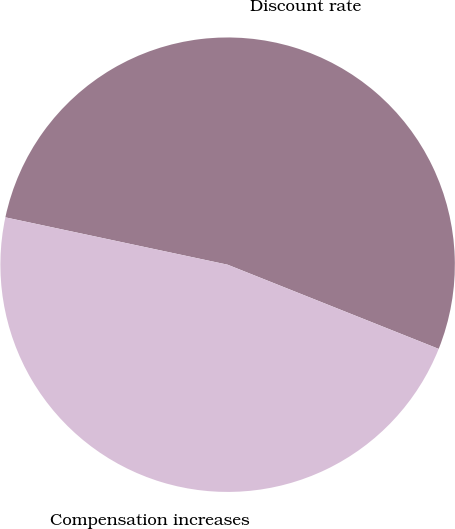Convert chart. <chart><loc_0><loc_0><loc_500><loc_500><pie_chart><fcel>Discount rate<fcel>Compensation increases<nl><fcel>52.7%<fcel>47.3%<nl></chart> 